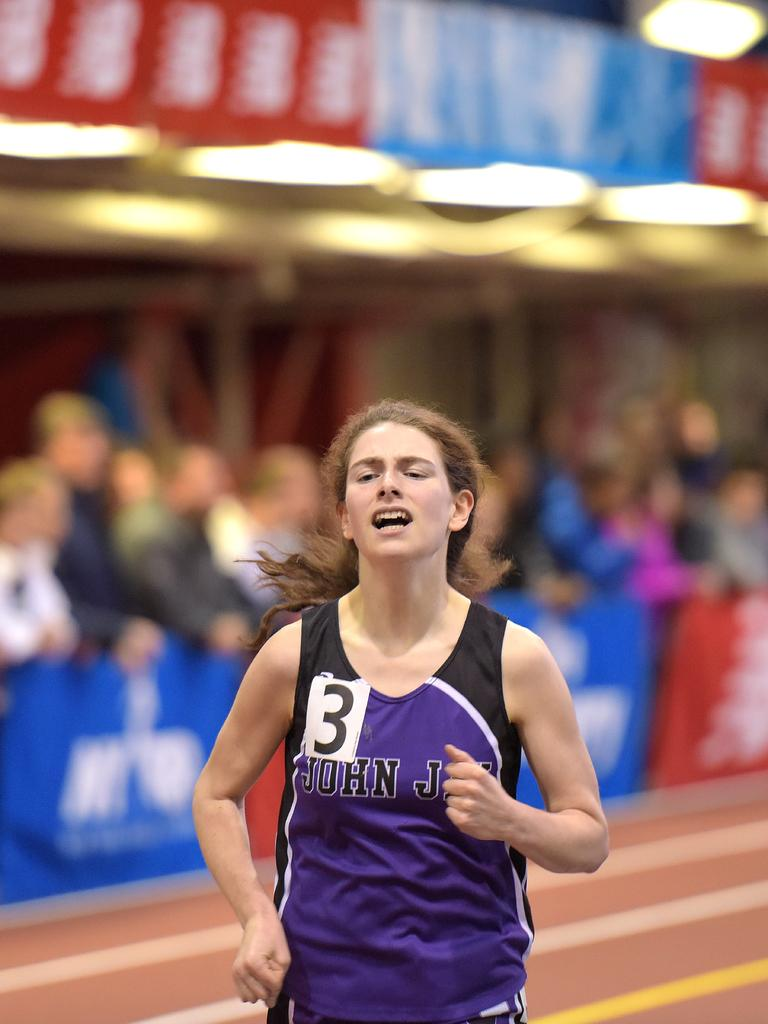<image>
Relay a brief, clear account of the picture shown. Runner number three for John Jay is running and seems to be in pain. 